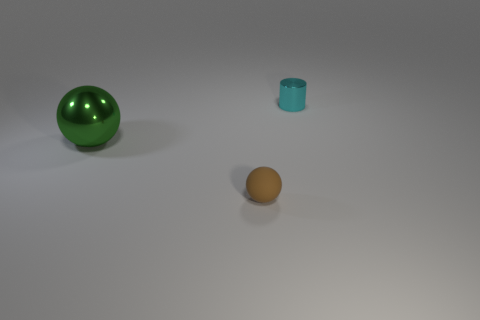What number of objects are tiny brown matte balls or spheres that are to the right of the big ball?
Give a very brief answer. 1. What is the material of the small object that is on the right side of the tiny object on the left side of the thing behind the green shiny thing?
Your answer should be compact. Metal. The cyan thing that is the same material as the large green sphere is what size?
Keep it short and to the point. Small. The metallic object in front of the metallic object on the right side of the small rubber object is what color?
Offer a very short reply. Green. How many big gray objects are the same material as the big green sphere?
Provide a short and direct response. 0. What number of shiny objects are either cyan objects or brown things?
Your response must be concise. 1. There is another object that is the same size as the cyan metallic thing; what is its material?
Provide a short and direct response. Rubber. Is there a big yellow block made of the same material as the cylinder?
Your answer should be compact. No. What is the shape of the metal thing on the right side of the metallic object that is on the left side of the metal cylinder that is to the right of the brown rubber ball?
Give a very brief answer. Cylinder. Do the brown ball and the shiny thing that is behind the big green metallic ball have the same size?
Offer a very short reply. Yes. 